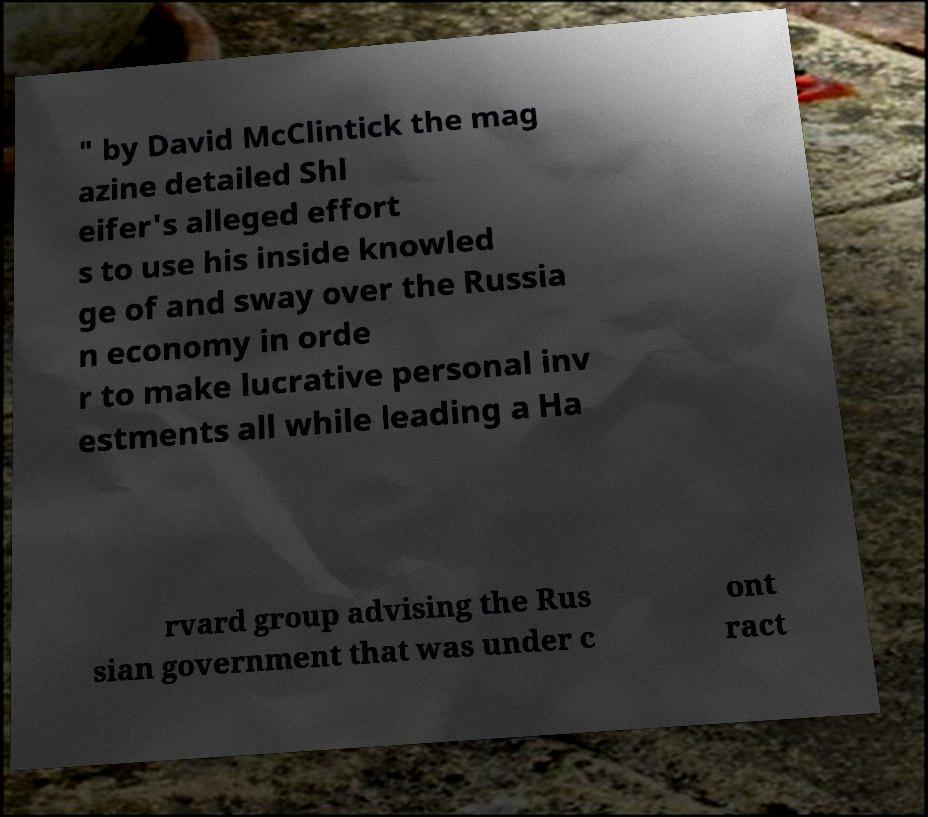I need the written content from this picture converted into text. Can you do that? " by David McClintick the mag azine detailed Shl eifer's alleged effort s to use his inside knowled ge of and sway over the Russia n economy in orde r to make lucrative personal inv estments all while leading a Ha rvard group advising the Rus sian government that was under c ont ract 